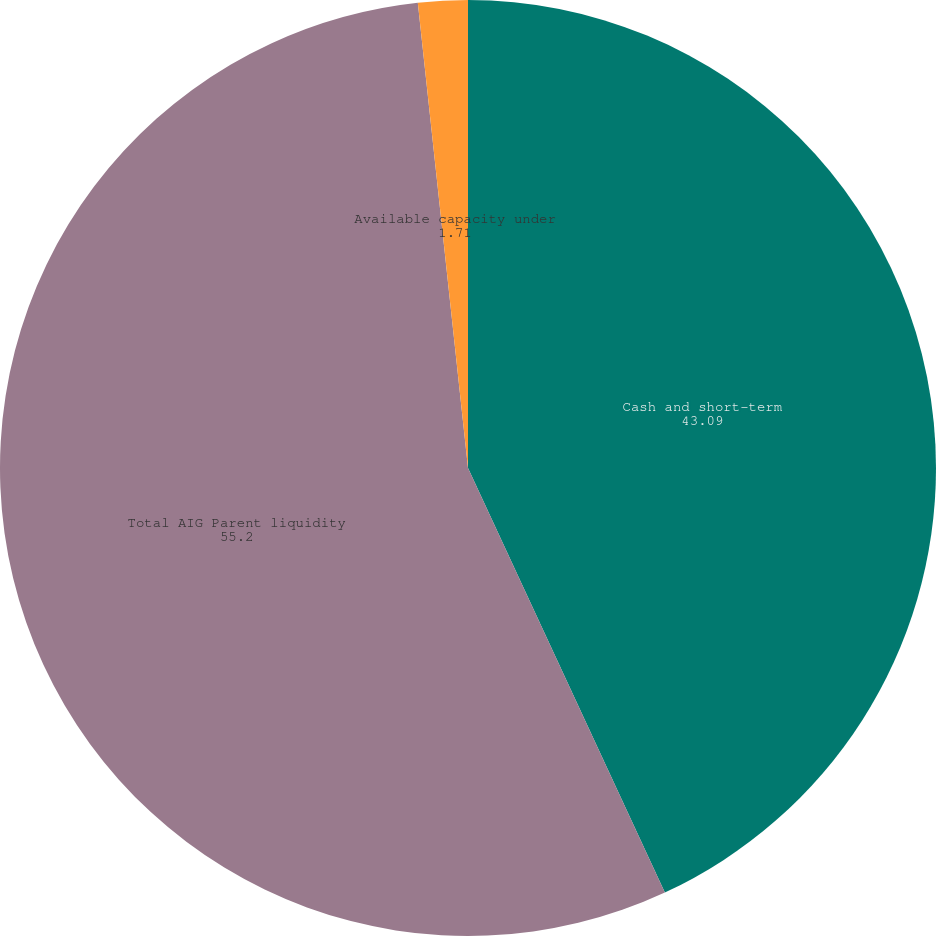Convert chart. <chart><loc_0><loc_0><loc_500><loc_500><pie_chart><fcel>Cash and short-term<fcel>Total AIG Parent liquidity<fcel>Available capacity under<nl><fcel>43.09%<fcel>55.2%<fcel>1.71%<nl></chart> 